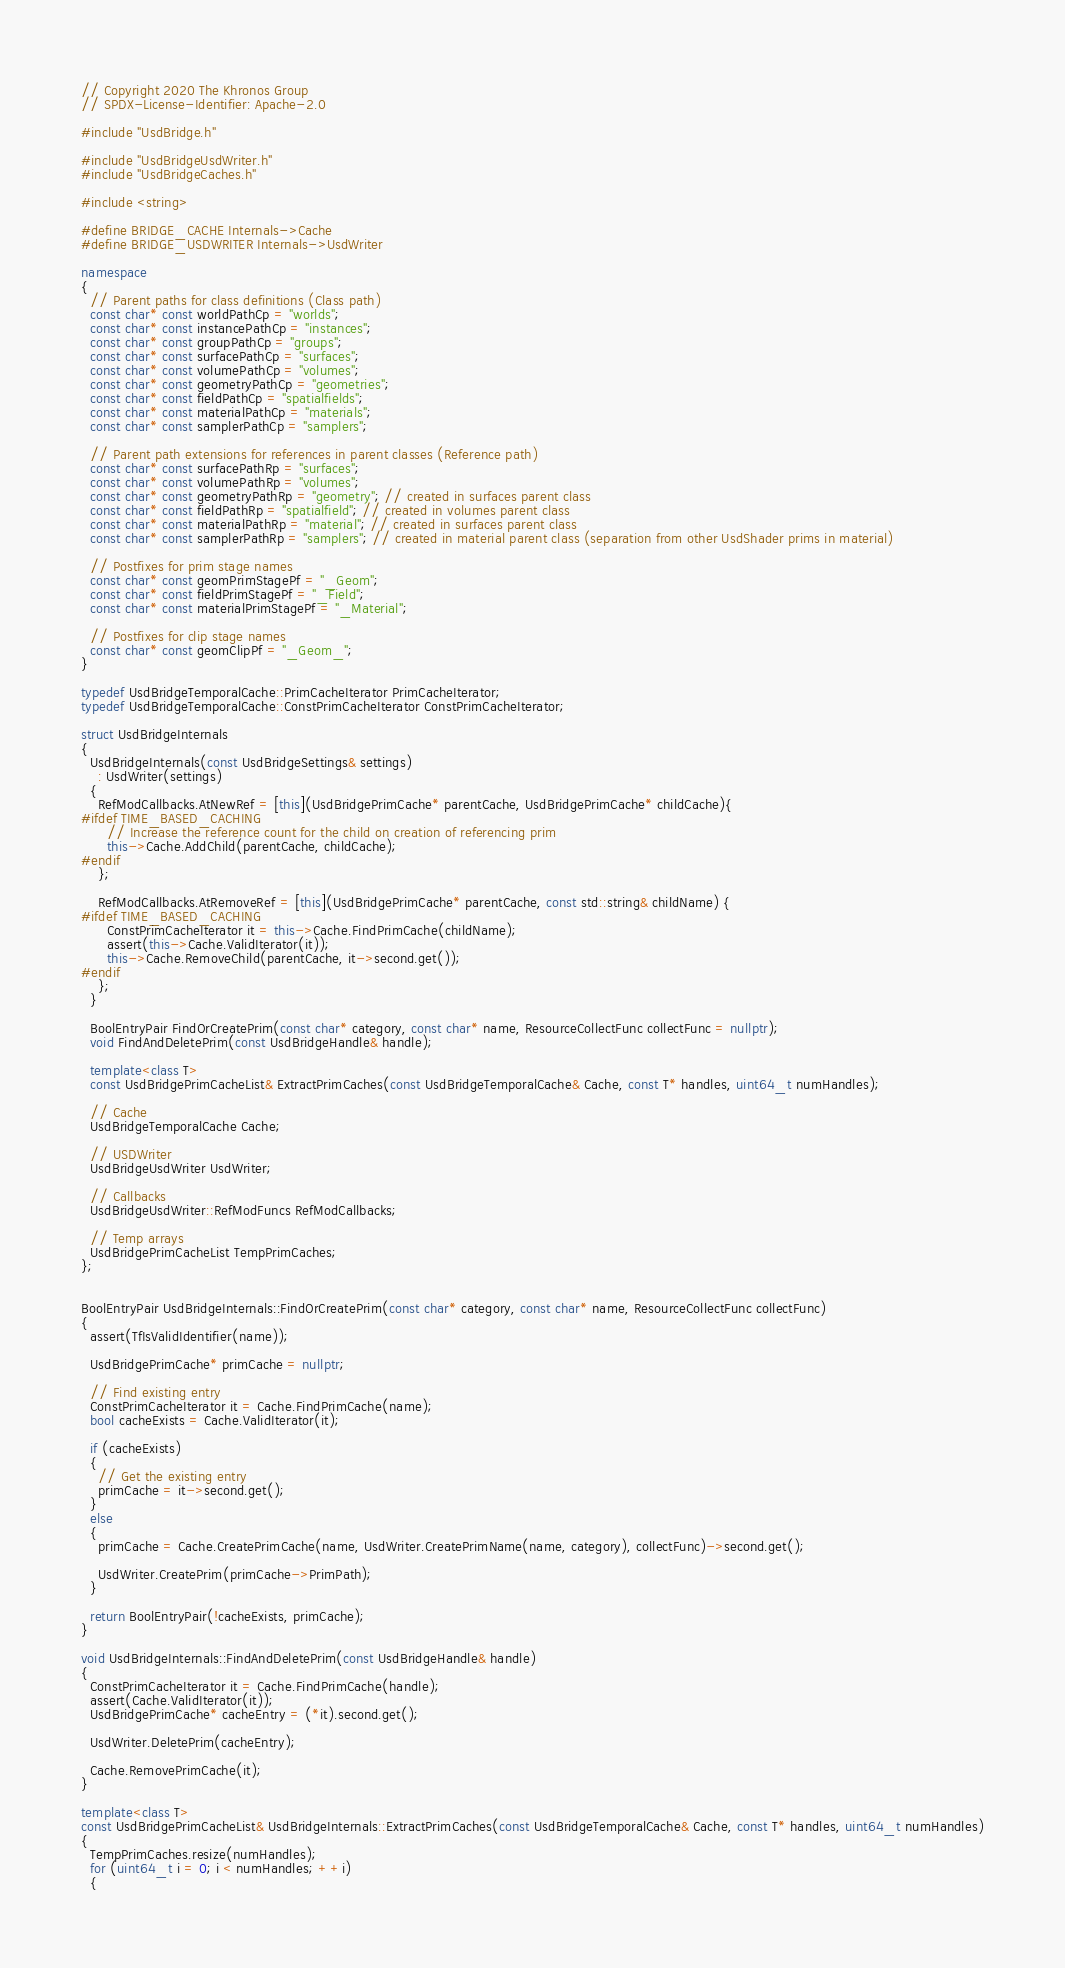<code> <loc_0><loc_0><loc_500><loc_500><_C++_>// Copyright 2020 The Khronos Group
// SPDX-License-Identifier: Apache-2.0

#include "UsdBridge.h"

#include "UsdBridgeUsdWriter.h"
#include "UsdBridgeCaches.h"

#include <string>

#define BRIDGE_CACHE Internals->Cache
#define BRIDGE_USDWRITER Internals->UsdWriter

namespace
{
  // Parent paths for class definitions (Class path)
  const char* const worldPathCp = "worlds";
  const char* const instancePathCp = "instances";
  const char* const groupPathCp = "groups";
  const char* const surfacePathCp = "surfaces";
  const char* const volumePathCp = "volumes";
  const char* const geometryPathCp = "geometries";
  const char* const fieldPathCp = "spatialfields";
  const char* const materialPathCp = "materials";
  const char* const samplerPathCp = "samplers";

  // Parent path extensions for references in parent classes (Reference path)
  const char* const surfacePathRp = "surfaces";
  const char* const volumePathRp = "volumes";
  const char* const geometryPathRp = "geometry"; // created in surfaces parent class
  const char* const fieldPathRp = "spatialfield"; // created in volumes parent class
  const char* const materialPathRp = "material"; // created in surfaces parent class
  const char* const samplerPathRp = "samplers"; // created in material parent class (separation from other UsdShader prims in material)

  // Postfixes for prim stage names
  const char* const geomPrimStagePf = "_Geom";
  const char* const fieldPrimStagePf = "_Field";
  const char* const materialPrimStagePf = "_Material";

  // Postfixes for clip stage names
  const char* const geomClipPf = "_Geom_";
}

typedef UsdBridgeTemporalCache::PrimCacheIterator PrimCacheIterator;
typedef UsdBridgeTemporalCache::ConstPrimCacheIterator ConstPrimCacheIterator;

struct UsdBridgeInternals
{
  UsdBridgeInternals(const UsdBridgeSettings& settings)
    : UsdWriter(settings)
  {
    RefModCallbacks.AtNewRef = [this](UsdBridgePrimCache* parentCache, UsdBridgePrimCache* childCache){
#ifdef TIME_BASED_CACHING
      // Increase the reference count for the child on creation of referencing prim
      this->Cache.AddChild(parentCache, childCache);
#endif
    };

    RefModCallbacks.AtRemoveRef = [this](UsdBridgePrimCache* parentCache, const std::string& childName) {
#ifdef TIME_BASED_CACHING
      ConstPrimCacheIterator it = this->Cache.FindPrimCache(childName);
      assert(this->Cache.ValidIterator(it));
      this->Cache.RemoveChild(parentCache, it->second.get());
#endif
    };
  }

  BoolEntryPair FindOrCreatePrim(const char* category, const char* name, ResourceCollectFunc collectFunc = nullptr);
  void FindAndDeletePrim(const UsdBridgeHandle& handle);

  template<class T>
  const UsdBridgePrimCacheList& ExtractPrimCaches(const UsdBridgeTemporalCache& Cache, const T* handles, uint64_t numHandles);

  // Cache
  UsdBridgeTemporalCache Cache;

  // USDWriter
  UsdBridgeUsdWriter UsdWriter;

  // Callbacks
  UsdBridgeUsdWriter::RefModFuncs RefModCallbacks;

  // Temp arrays
  UsdBridgePrimCacheList TempPrimCaches;
};


BoolEntryPair UsdBridgeInternals::FindOrCreatePrim(const char* category, const char* name, ResourceCollectFunc collectFunc)
{
  assert(TfIsValidIdentifier(name));

  UsdBridgePrimCache* primCache = nullptr;

  // Find existing entry
  ConstPrimCacheIterator it = Cache.FindPrimCache(name);
  bool cacheExists = Cache.ValidIterator(it);

  if (cacheExists)
  {
    // Get the existing entry
    primCache = it->second.get();
  }
  else
  {
    primCache = Cache.CreatePrimCache(name, UsdWriter.CreatePrimName(name, category), collectFunc)->second.get();

    UsdWriter.CreatePrim(primCache->PrimPath);
  }

  return BoolEntryPair(!cacheExists, primCache);
}

void UsdBridgeInternals::FindAndDeletePrim(const UsdBridgeHandle& handle)
{
  ConstPrimCacheIterator it = Cache.FindPrimCache(handle);
  assert(Cache.ValidIterator(it));
  UsdBridgePrimCache* cacheEntry = (*it).second.get();

  UsdWriter.DeletePrim(cacheEntry);

  Cache.RemovePrimCache(it);
}

template<class T>
const UsdBridgePrimCacheList& UsdBridgeInternals::ExtractPrimCaches(const UsdBridgeTemporalCache& Cache, const T* handles, uint64_t numHandles)
{
  TempPrimCaches.resize(numHandles);
  for (uint64_t i = 0; i < numHandles; ++i)
  {</code> 